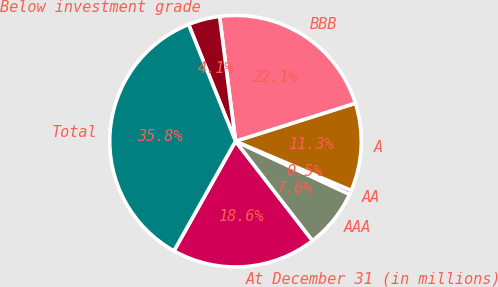<chart> <loc_0><loc_0><loc_500><loc_500><pie_chart><fcel>At December 31 (in millions)<fcel>AAA<fcel>AA<fcel>A<fcel>BBB<fcel>Below investment grade<fcel>Total<nl><fcel>18.62%<fcel>7.58%<fcel>0.54%<fcel>11.28%<fcel>22.14%<fcel>4.06%<fcel>35.78%<nl></chart> 